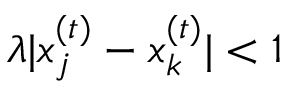Convert formula to latex. <formula><loc_0><loc_0><loc_500><loc_500>\lambda | x _ { j } ^ { ( t ) } - x _ { k } ^ { ( t ) } | < 1</formula> 